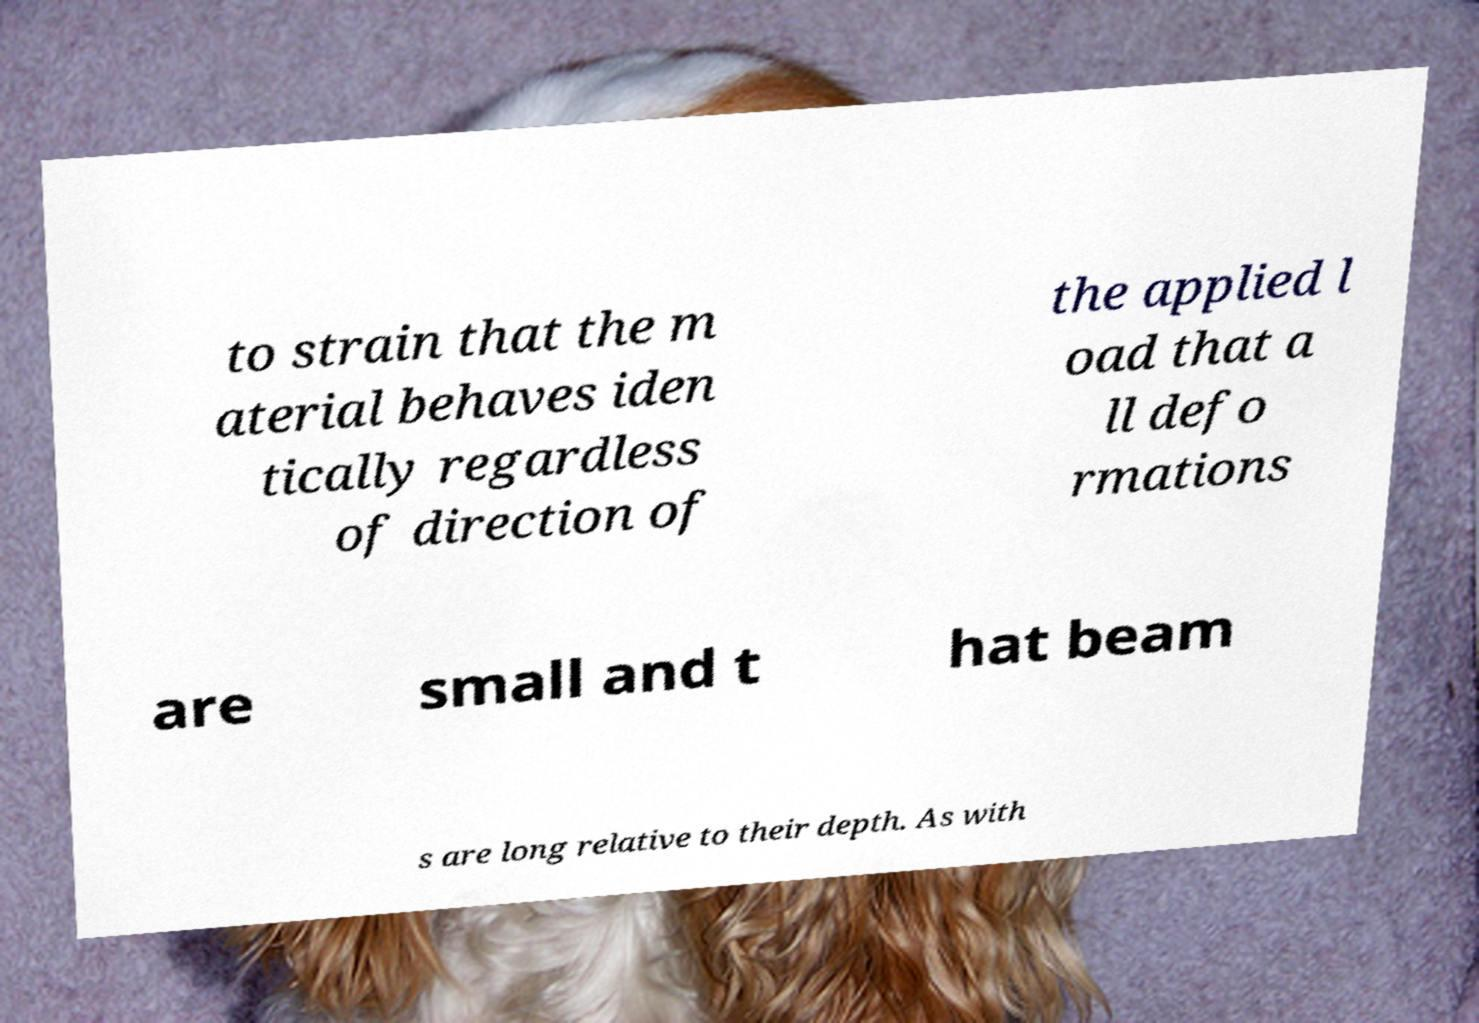Could you assist in decoding the text presented in this image and type it out clearly? to strain that the m aterial behaves iden tically regardless of direction of the applied l oad that a ll defo rmations are small and t hat beam s are long relative to their depth. As with 